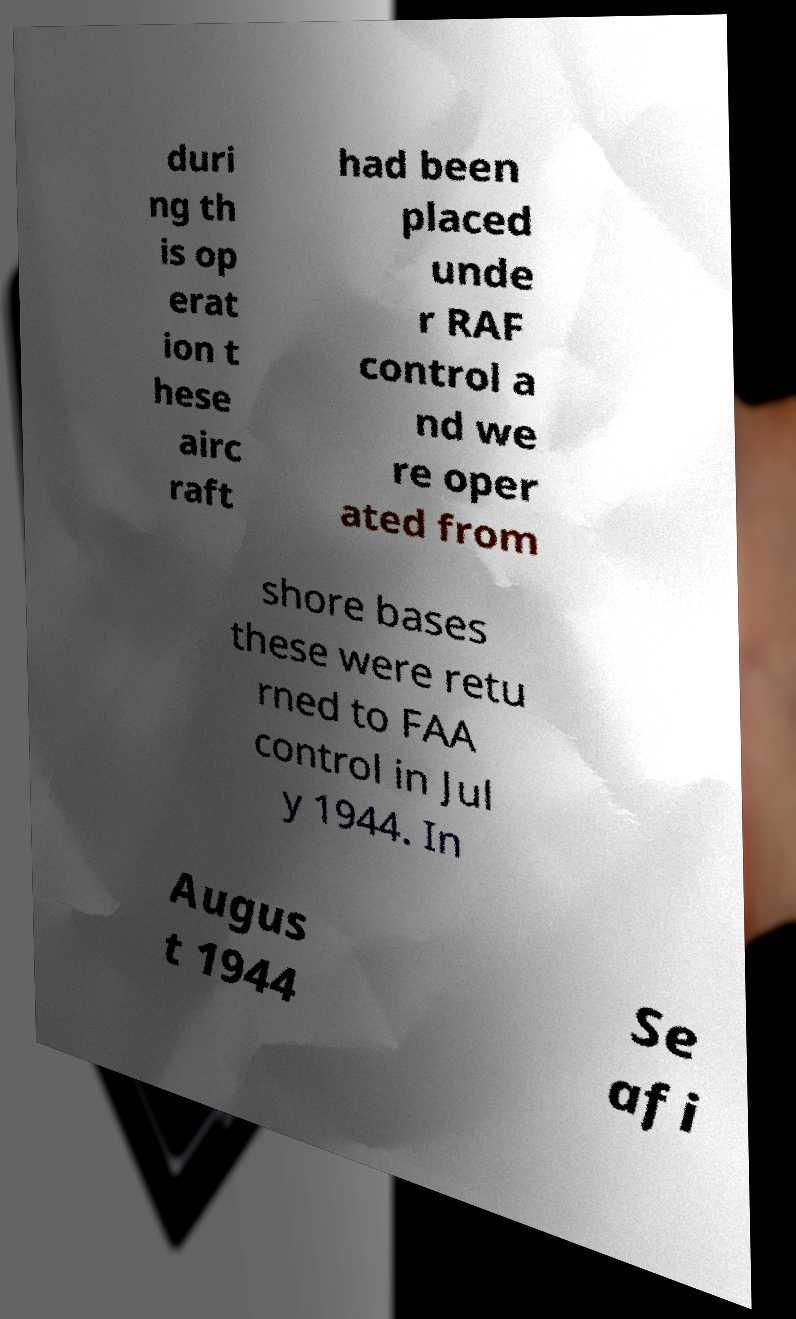Please identify and transcribe the text found in this image. duri ng th is op erat ion t hese airc raft had been placed unde r RAF control a nd we re oper ated from shore bases these were retu rned to FAA control in Jul y 1944. In Augus t 1944 Se afi 